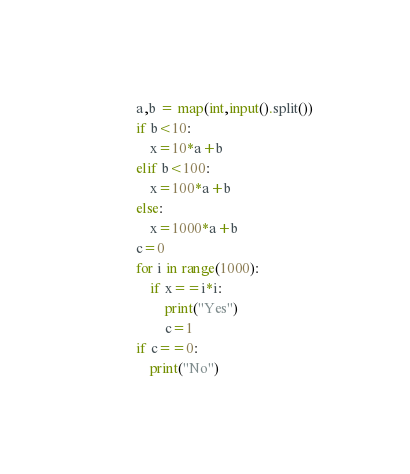Convert code to text. <code><loc_0><loc_0><loc_500><loc_500><_Python_>a,b = map(int,input().split())
if b<10:
    x=10*a+b
elif b<100:
    x=100*a+b
else:
    x=1000*a+b
c=0
for i in range(1000):
    if x==i*i:
        print("Yes")
        c=1
if c==0:      
    print("No")

</code> 